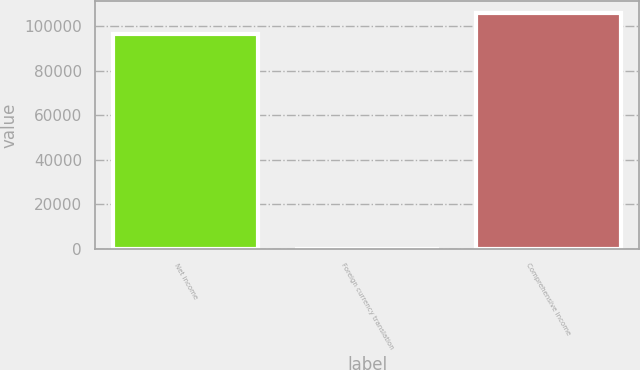Convert chart to OTSL. <chart><loc_0><loc_0><loc_500><loc_500><bar_chart><fcel>Net income<fcel>Foreign currency translation<fcel>Comprehensive income<nl><fcel>96241<fcel>22<fcel>105865<nl></chart> 